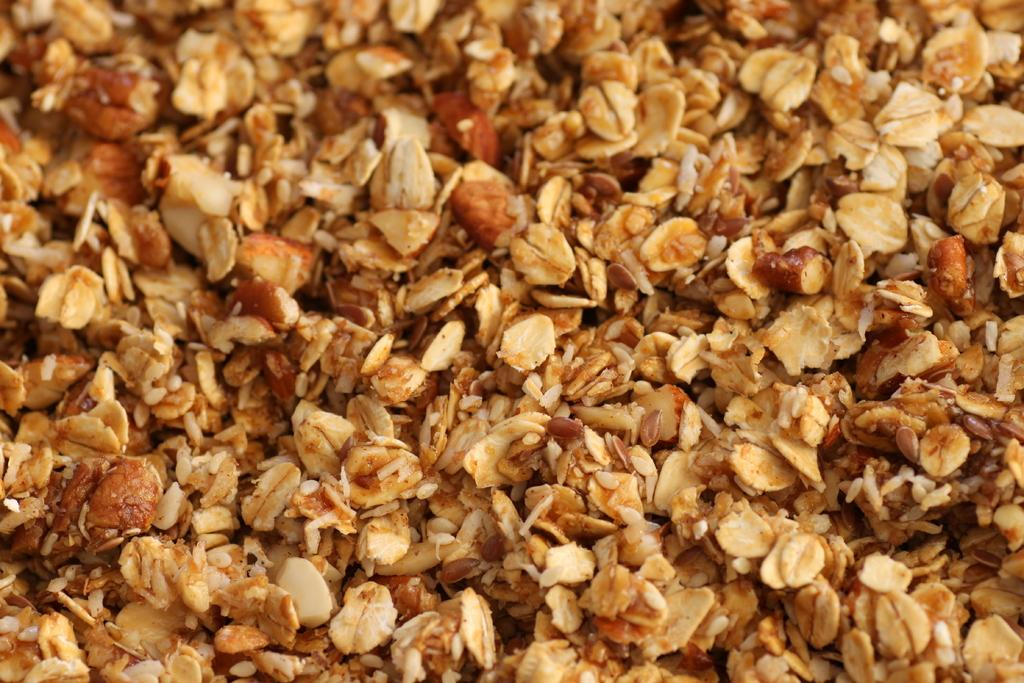What can be seen in the image? There is food in the image. How many jellyfish are swimming in the food in the image? There are no jellyfish present in the image, as it only contains food. 